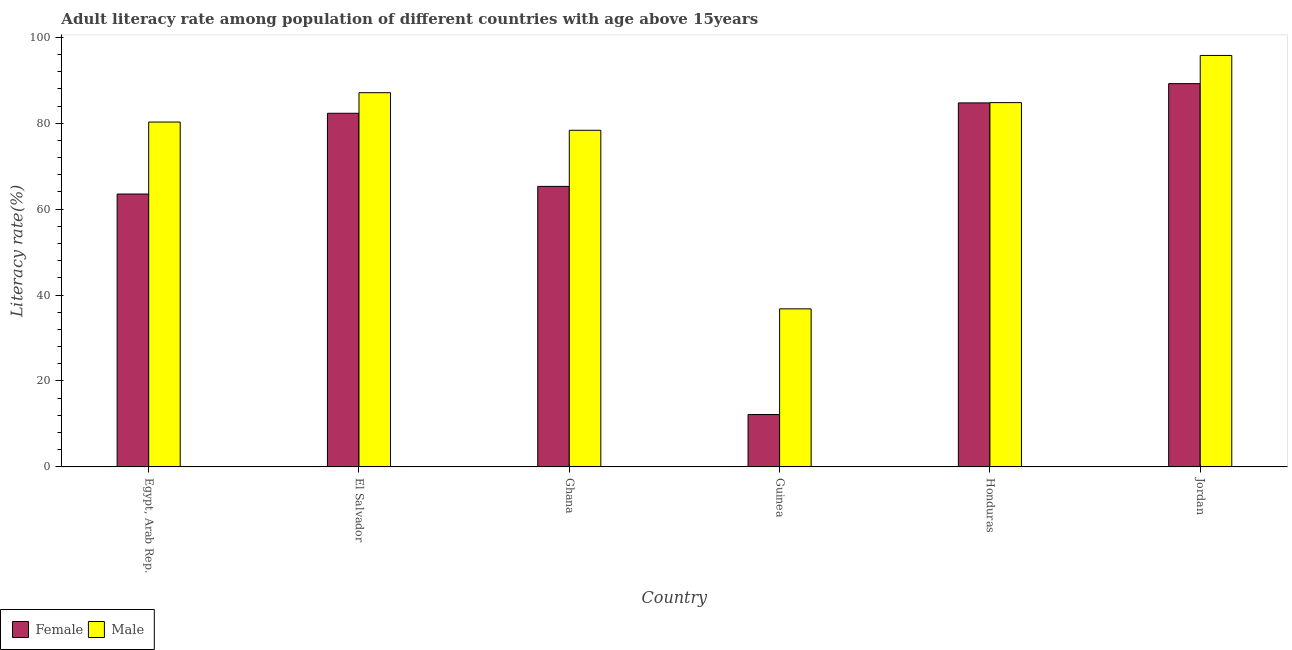How many different coloured bars are there?
Give a very brief answer. 2. Are the number of bars per tick equal to the number of legend labels?
Provide a short and direct response. Yes. Are the number of bars on each tick of the X-axis equal?
Provide a succinct answer. Yes. What is the label of the 6th group of bars from the left?
Your answer should be compact. Jordan. In how many cases, is the number of bars for a given country not equal to the number of legend labels?
Offer a terse response. 0. What is the male adult literacy rate in El Salvador?
Offer a very short reply. 87.1. Across all countries, what is the maximum male adult literacy rate?
Ensure brevity in your answer.  95.77. Across all countries, what is the minimum male adult literacy rate?
Ensure brevity in your answer.  36.79. In which country was the female adult literacy rate maximum?
Your response must be concise. Jordan. In which country was the female adult literacy rate minimum?
Keep it short and to the point. Guinea. What is the total female adult literacy rate in the graph?
Keep it short and to the point. 397.24. What is the difference between the male adult literacy rate in Egypt, Arab Rep. and that in Guinea?
Ensure brevity in your answer.  43.48. What is the difference between the male adult literacy rate in Honduras and the female adult literacy rate in Jordan?
Your response must be concise. -4.42. What is the average male adult literacy rate per country?
Provide a short and direct response. 77.18. What is the difference between the male adult literacy rate and female adult literacy rate in Jordan?
Your answer should be compact. 6.56. What is the ratio of the male adult literacy rate in Egypt, Arab Rep. to that in Jordan?
Offer a very short reply. 0.84. Is the difference between the female adult literacy rate in Guinea and Honduras greater than the difference between the male adult literacy rate in Guinea and Honduras?
Your response must be concise. No. What is the difference between the highest and the second highest female adult literacy rate?
Offer a terse response. 4.48. What is the difference between the highest and the lowest female adult literacy rate?
Your response must be concise. 77.02. In how many countries, is the female adult literacy rate greater than the average female adult literacy rate taken over all countries?
Make the answer very short. 3. What does the 1st bar from the right in Egypt, Arab Rep. represents?
Keep it short and to the point. Male. What is the difference between two consecutive major ticks on the Y-axis?
Offer a very short reply. 20. Does the graph contain any zero values?
Provide a succinct answer. No. What is the title of the graph?
Your response must be concise. Adult literacy rate among population of different countries with age above 15years. What is the label or title of the Y-axis?
Your answer should be very brief. Literacy rate(%). What is the Literacy rate(%) in Female in Egypt, Arab Rep.?
Your answer should be very brief. 63.52. What is the Literacy rate(%) in Male in Egypt, Arab Rep.?
Ensure brevity in your answer.  80.27. What is the Literacy rate(%) of Female in El Salvador?
Your answer should be very brief. 82.31. What is the Literacy rate(%) of Male in El Salvador?
Your response must be concise. 87.1. What is the Literacy rate(%) in Female in Ghana?
Your answer should be compact. 65.29. What is the Literacy rate(%) in Male in Ghana?
Your answer should be very brief. 78.35. What is the Literacy rate(%) in Female in Guinea?
Your answer should be very brief. 12.19. What is the Literacy rate(%) in Male in Guinea?
Offer a terse response. 36.79. What is the Literacy rate(%) of Female in Honduras?
Offer a terse response. 84.73. What is the Literacy rate(%) in Male in Honduras?
Make the answer very short. 84.79. What is the Literacy rate(%) in Female in Jordan?
Keep it short and to the point. 89.21. What is the Literacy rate(%) of Male in Jordan?
Ensure brevity in your answer.  95.77. Across all countries, what is the maximum Literacy rate(%) in Female?
Ensure brevity in your answer.  89.21. Across all countries, what is the maximum Literacy rate(%) in Male?
Give a very brief answer. 95.77. Across all countries, what is the minimum Literacy rate(%) of Female?
Your response must be concise. 12.19. Across all countries, what is the minimum Literacy rate(%) of Male?
Your answer should be compact. 36.79. What is the total Literacy rate(%) of Female in the graph?
Give a very brief answer. 397.24. What is the total Literacy rate(%) of Male in the graph?
Offer a terse response. 463.06. What is the difference between the Literacy rate(%) in Female in Egypt, Arab Rep. and that in El Salvador?
Ensure brevity in your answer.  -18.79. What is the difference between the Literacy rate(%) of Male in Egypt, Arab Rep. and that in El Salvador?
Provide a succinct answer. -6.83. What is the difference between the Literacy rate(%) of Female in Egypt, Arab Rep. and that in Ghana?
Make the answer very short. -1.78. What is the difference between the Literacy rate(%) in Male in Egypt, Arab Rep. and that in Ghana?
Give a very brief answer. 1.92. What is the difference between the Literacy rate(%) in Female in Egypt, Arab Rep. and that in Guinea?
Keep it short and to the point. 51.32. What is the difference between the Literacy rate(%) in Male in Egypt, Arab Rep. and that in Guinea?
Offer a very short reply. 43.48. What is the difference between the Literacy rate(%) of Female in Egypt, Arab Rep. and that in Honduras?
Give a very brief answer. -21.21. What is the difference between the Literacy rate(%) of Male in Egypt, Arab Rep. and that in Honduras?
Offer a very short reply. -4.52. What is the difference between the Literacy rate(%) of Female in Egypt, Arab Rep. and that in Jordan?
Provide a succinct answer. -25.69. What is the difference between the Literacy rate(%) of Male in Egypt, Arab Rep. and that in Jordan?
Your response must be concise. -15.5. What is the difference between the Literacy rate(%) in Female in El Salvador and that in Ghana?
Provide a succinct answer. 17.01. What is the difference between the Literacy rate(%) in Male in El Salvador and that in Ghana?
Provide a succinct answer. 8.75. What is the difference between the Literacy rate(%) of Female in El Salvador and that in Guinea?
Provide a succinct answer. 70.12. What is the difference between the Literacy rate(%) of Male in El Salvador and that in Guinea?
Offer a terse response. 50.31. What is the difference between the Literacy rate(%) of Female in El Salvador and that in Honduras?
Your answer should be very brief. -2.42. What is the difference between the Literacy rate(%) in Male in El Salvador and that in Honduras?
Give a very brief answer. 2.31. What is the difference between the Literacy rate(%) of Female in El Salvador and that in Jordan?
Keep it short and to the point. -6.9. What is the difference between the Literacy rate(%) in Male in El Salvador and that in Jordan?
Offer a terse response. -8.67. What is the difference between the Literacy rate(%) of Female in Ghana and that in Guinea?
Your response must be concise. 53.1. What is the difference between the Literacy rate(%) of Male in Ghana and that in Guinea?
Provide a succinct answer. 41.56. What is the difference between the Literacy rate(%) in Female in Ghana and that in Honduras?
Offer a terse response. -19.43. What is the difference between the Literacy rate(%) in Male in Ghana and that in Honduras?
Your response must be concise. -6.44. What is the difference between the Literacy rate(%) of Female in Ghana and that in Jordan?
Your answer should be very brief. -23.91. What is the difference between the Literacy rate(%) in Male in Ghana and that in Jordan?
Give a very brief answer. -17.42. What is the difference between the Literacy rate(%) of Female in Guinea and that in Honduras?
Offer a very short reply. -72.53. What is the difference between the Literacy rate(%) of Male in Guinea and that in Honduras?
Offer a very short reply. -48. What is the difference between the Literacy rate(%) of Female in Guinea and that in Jordan?
Make the answer very short. -77.02. What is the difference between the Literacy rate(%) of Male in Guinea and that in Jordan?
Keep it short and to the point. -58.98. What is the difference between the Literacy rate(%) in Female in Honduras and that in Jordan?
Ensure brevity in your answer.  -4.48. What is the difference between the Literacy rate(%) of Male in Honduras and that in Jordan?
Keep it short and to the point. -10.98. What is the difference between the Literacy rate(%) in Female in Egypt, Arab Rep. and the Literacy rate(%) in Male in El Salvador?
Make the answer very short. -23.58. What is the difference between the Literacy rate(%) of Female in Egypt, Arab Rep. and the Literacy rate(%) of Male in Ghana?
Keep it short and to the point. -14.83. What is the difference between the Literacy rate(%) in Female in Egypt, Arab Rep. and the Literacy rate(%) in Male in Guinea?
Keep it short and to the point. 26.73. What is the difference between the Literacy rate(%) of Female in Egypt, Arab Rep. and the Literacy rate(%) of Male in Honduras?
Your response must be concise. -21.27. What is the difference between the Literacy rate(%) in Female in Egypt, Arab Rep. and the Literacy rate(%) in Male in Jordan?
Make the answer very short. -32.25. What is the difference between the Literacy rate(%) in Female in El Salvador and the Literacy rate(%) in Male in Ghana?
Your answer should be very brief. 3.96. What is the difference between the Literacy rate(%) in Female in El Salvador and the Literacy rate(%) in Male in Guinea?
Provide a short and direct response. 45.52. What is the difference between the Literacy rate(%) of Female in El Salvador and the Literacy rate(%) of Male in Honduras?
Provide a succinct answer. -2.48. What is the difference between the Literacy rate(%) in Female in El Salvador and the Literacy rate(%) in Male in Jordan?
Your answer should be very brief. -13.46. What is the difference between the Literacy rate(%) in Female in Ghana and the Literacy rate(%) in Male in Guinea?
Your answer should be very brief. 28.5. What is the difference between the Literacy rate(%) in Female in Ghana and the Literacy rate(%) in Male in Honduras?
Offer a terse response. -19.49. What is the difference between the Literacy rate(%) in Female in Ghana and the Literacy rate(%) in Male in Jordan?
Your answer should be compact. -30.47. What is the difference between the Literacy rate(%) of Female in Guinea and the Literacy rate(%) of Male in Honduras?
Your answer should be very brief. -72.6. What is the difference between the Literacy rate(%) in Female in Guinea and the Literacy rate(%) in Male in Jordan?
Offer a very short reply. -83.58. What is the difference between the Literacy rate(%) in Female in Honduras and the Literacy rate(%) in Male in Jordan?
Keep it short and to the point. -11.04. What is the average Literacy rate(%) of Female per country?
Ensure brevity in your answer.  66.21. What is the average Literacy rate(%) in Male per country?
Your response must be concise. 77.18. What is the difference between the Literacy rate(%) in Female and Literacy rate(%) in Male in Egypt, Arab Rep.?
Your response must be concise. -16.75. What is the difference between the Literacy rate(%) of Female and Literacy rate(%) of Male in El Salvador?
Give a very brief answer. -4.79. What is the difference between the Literacy rate(%) of Female and Literacy rate(%) of Male in Ghana?
Offer a terse response. -13.05. What is the difference between the Literacy rate(%) of Female and Literacy rate(%) of Male in Guinea?
Ensure brevity in your answer.  -24.6. What is the difference between the Literacy rate(%) in Female and Literacy rate(%) in Male in Honduras?
Give a very brief answer. -0.06. What is the difference between the Literacy rate(%) in Female and Literacy rate(%) in Male in Jordan?
Keep it short and to the point. -6.56. What is the ratio of the Literacy rate(%) in Female in Egypt, Arab Rep. to that in El Salvador?
Offer a terse response. 0.77. What is the ratio of the Literacy rate(%) of Male in Egypt, Arab Rep. to that in El Salvador?
Give a very brief answer. 0.92. What is the ratio of the Literacy rate(%) in Female in Egypt, Arab Rep. to that in Ghana?
Provide a succinct answer. 0.97. What is the ratio of the Literacy rate(%) in Male in Egypt, Arab Rep. to that in Ghana?
Offer a terse response. 1.02. What is the ratio of the Literacy rate(%) in Female in Egypt, Arab Rep. to that in Guinea?
Offer a terse response. 5.21. What is the ratio of the Literacy rate(%) of Male in Egypt, Arab Rep. to that in Guinea?
Offer a terse response. 2.18. What is the ratio of the Literacy rate(%) of Female in Egypt, Arab Rep. to that in Honduras?
Offer a terse response. 0.75. What is the ratio of the Literacy rate(%) in Male in Egypt, Arab Rep. to that in Honduras?
Provide a succinct answer. 0.95. What is the ratio of the Literacy rate(%) of Female in Egypt, Arab Rep. to that in Jordan?
Provide a succinct answer. 0.71. What is the ratio of the Literacy rate(%) of Male in Egypt, Arab Rep. to that in Jordan?
Your answer should be very brief. 0.84. What is the ratio of the Literacy rate(%) of Female in El Salvador to that in Ghana?
Offer a very short reply. 1.26. What is the ratio of the Literacy rate(%) in Male in El Salvador to that in Ghana?
Your answer should be very brief. 1.11. What is the ratio of the Literacy rate(%) in Female in El Salvador to that in Guinea?
Provide a succinct answer. 6.75. What is the ratio of the Literacy rate(%) in Male in El Salvador to that in Guinea?
Your answer should be very brief. 2.37. What is the ratio of the Literacy rate(%) of Female in El Salvador to that in Honduras?
Your answer should be compact. 0.97. What is the ratio of the Literacy rate(%) of Male in El Salvador to that in Honduras?
Offer a very short reply. 1.03. What is the ratio of the Literacy rate(%) in Female in El Salvador to that in Jordan?
Offer a terse response. 0.92. What is the ratio of the Literacy rate(%) of Male in El Salvador to that in Jordan?
Keep it short and to the point. 0.91. What is the ratio of the Literacy rate(%) of Female in Ghana to that in Guinea?
Offer a very short reply. 5.36. What is the ratio of the Literacy rate(%) in Male in Ghana to that in Guinea?
Your answer should be very brief. 2.13. What is the ratio of the Literacy rate(%) in Female in Ghana to that in Honduras?
Make the answer very short. 0.77. What is the ratio of the Literacy rate(%) of Male in Ghana to that in Honduras?
Ensure brevity in your answer.  0.92. What is the ratio of the Literacy rate(%) of Female in Ghana to that in Jordan?
Keep it short and to the point. 0.73. What is the ratio of the Literacy rate(%) of Male in Ghana to that in Jordan?
Provide a succinct answer. 0.82. What is the ratio of the Literacy rate(%) in Female in Guinea to that in Honduras?
Your response must be concise. 0.14. What is the ratio of the Literacy rate(%) of Male in Guinea to that in Honduras?
Keep it short and to the point. 0.43. What is the ratio of the Literacy rate(%) of Female in Guinea to that in Jordan?
Make the answer very short. 0.14. What is the ratio of the Literacy rate(%) of Male in Guinea to that in Jordan?
Provide a short and direct response. 0.38. What is the ratio of the Literacy rate(%) in Female in Honduras to that in Jordan?
Keep it short and to the point. 0.95. What is the ratio of the Literacy rate(%) in Male in Honduras to that in Jordan?
Give a very brief answer. 0.89. What is the difference between the highest and the second highest Literacy rate(%) of Female?
Your answer should be very brief. 4.48. What is the difference between the highest and the second highest Literacy rate(%) of Male?
Ensure brevity in your answer.  8.67. What is the difference between the highest and the lowest Literacy rate(%) in Female?
Ensure brevity in your answer.  77.02. What is the difference between the highest and the lowest Literacy rate(%) of Male?
Give a very brief answer. 58.98. 